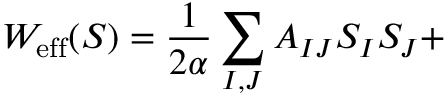Convert formula to latex. <formula><loc_0><loc_0><loc_500><loc_500>W _ { e f f } ( S ) = \frac { 1 } { 2 \alpha } \sum _ { I , J } A _ { I J } S _ { I } S _ { J } +</formula> 